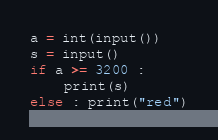Convert code to text. <code><loc_0><loc_0><loc_500><loc_500><_Python_>a = int(input())
s = input()
if a >= 3200 :
    print(s)
else : print("red")
</code> 